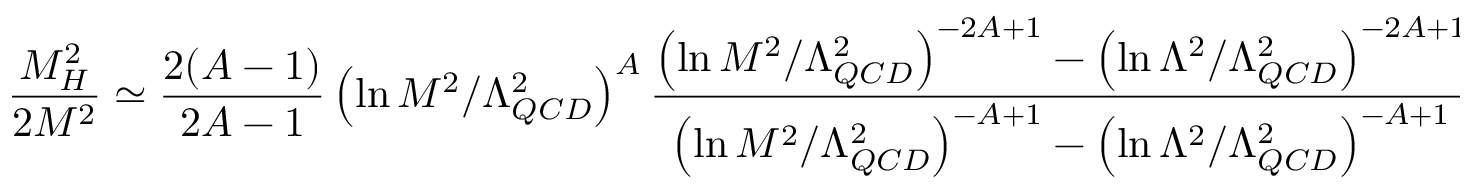<formula> <loc_0><loc_0><loc_500><loc_500>\frac { M _ { H } ^ { 2 } } { 2 M ^ { 2 } } \simeq \frac { 2 ( A - 1 ) } { 2 A - 1 } \left ( \ln M ^ { 2 } / \Lambda _ { Q C D } ^ { 2 } \right ) ^ { A } \frac { \left ( \ln M ^ { 2 } / \Lambda _ { Q C D } ^ { 2 } \right ) ^ { - 2 A + 1 } - \left ( \ln \Lambda ^ { 2 } / \Lambda _ { Q C D } ^ { 2 } \right ) ^ { - 2 A + 1 } } { \left ( \ln M ^ { 2 } / \Lambda _ { Q C D } ^ { 2 } \right ) ^ { - A + 1 } - \left ( \ln \Lambda ^ { 2 } / \Lambda _ { Q C D } ^ { 2 } \right ) ^ { - A + 1 } } .</formula> 